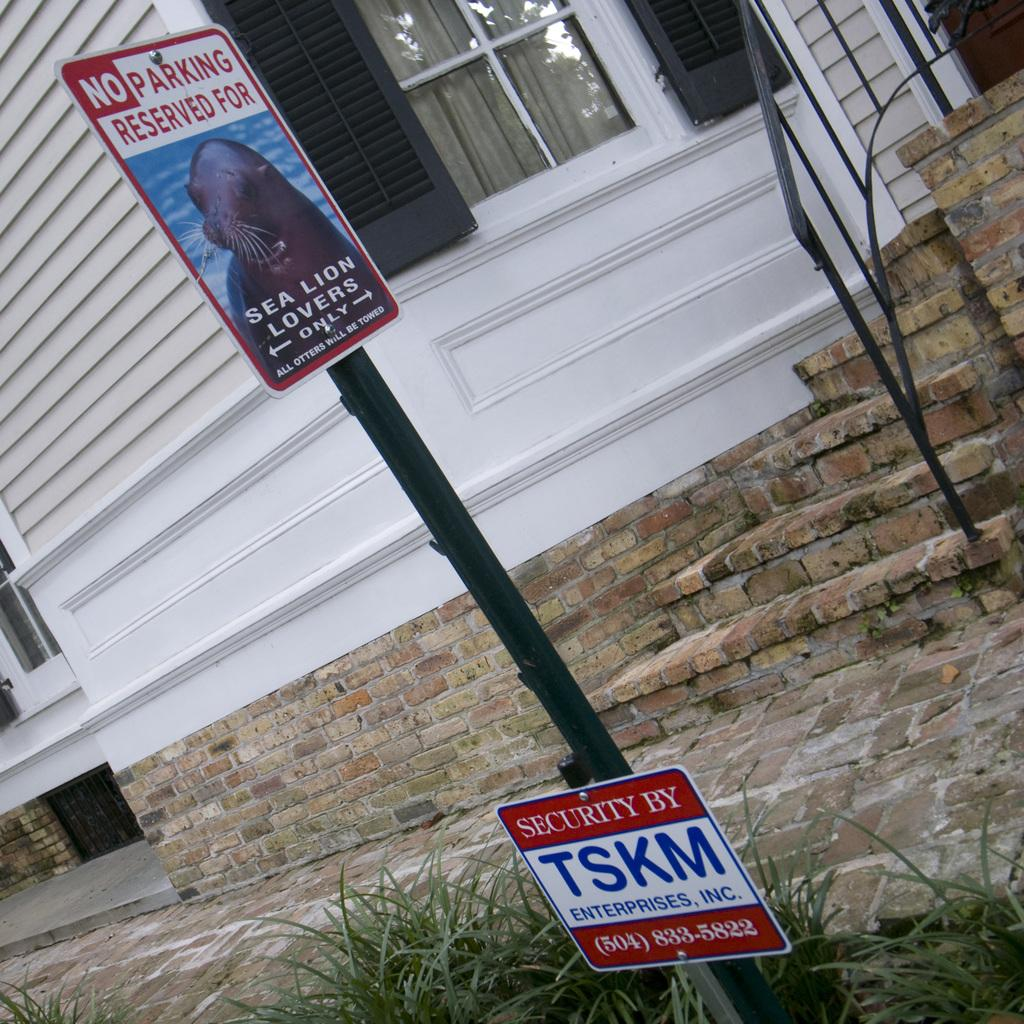What is the main object in the image? There is a pole in the image. What is attached to the pole? There are boards on the pole. What type of natural environment is visible in the image? There is grass visible in the image. What can be seen in the background of the image? There is a building in the background of the image. What type of insurance is being advertised on the pole in the image? There is no insurance being advertised on the pole in the image; it only has boards attached to it. 